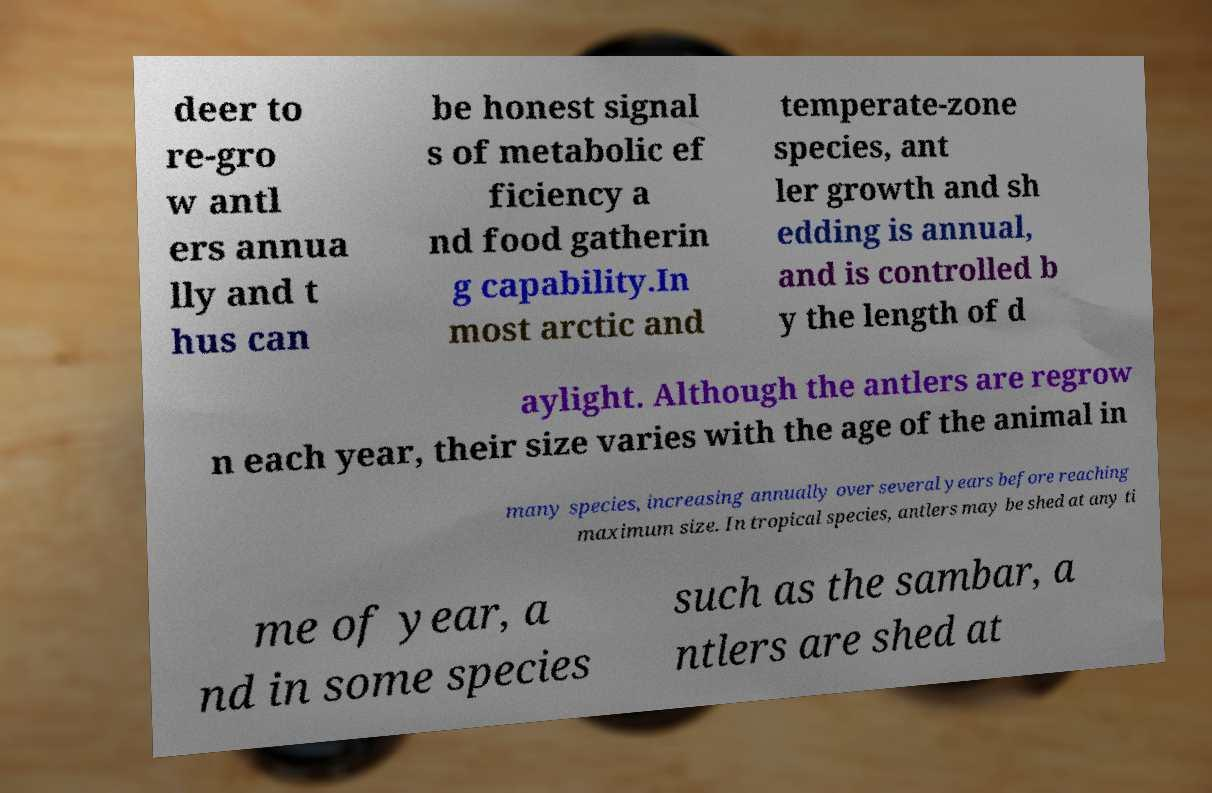What messages or text are displayed in this image? I need them in a readable, typed format. deer to re-gro w antl ers annua lly and t hus can be honest signal s of metabolic ef ficiency a nd food gatherin g capability.In most arctic and temperate-zone species, ant ler growth and sh edding is annual, and is controlled b y the length of d aylight. Although the antlers are regrow n each year, their size varies with the age of the animal in many species, increasing annually over several years before reaching maximum size. In tropical species, antlers may be shed at any ti me of year, a nd in some species such as the sambar, a ntlers are shed at 